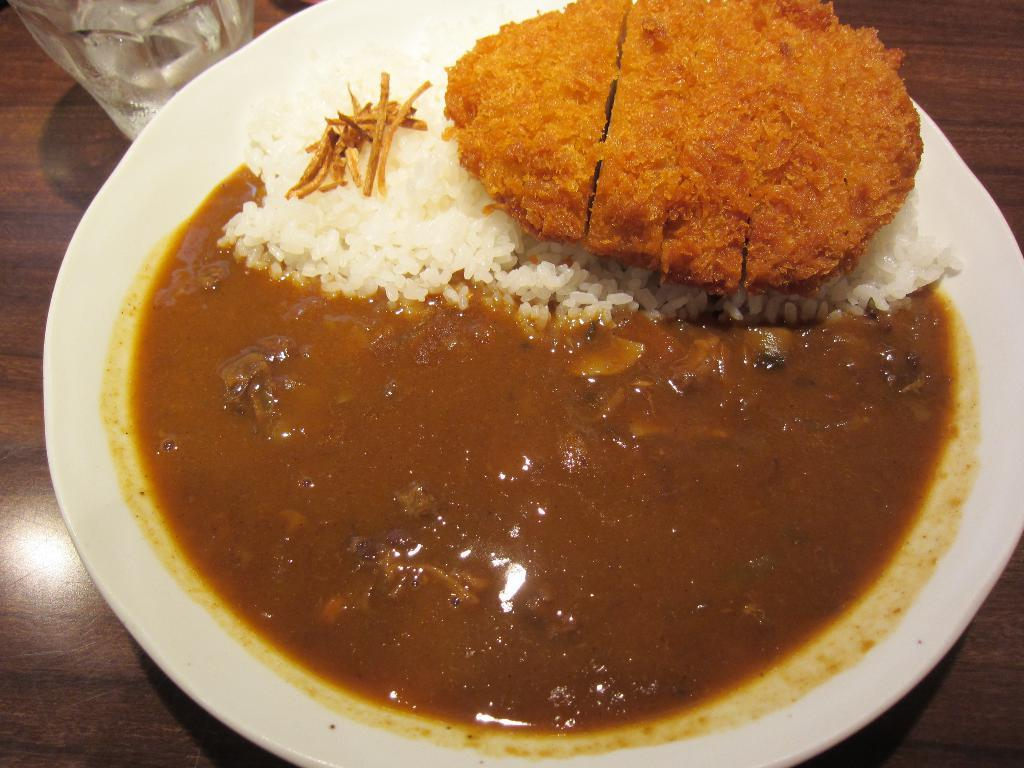What is on the plate in the image? There are food items on a plate in the image. What else can be seen on the wooden surface in the image? There is a glass on a wooden surface in the image. What type of patch is visible on the food items in the image? There is no patch visible on the food items in the image. What kind of fuel is being used by the spacecraft in the image? There is no spacecraft or fuel present in the image; it only features food items on a plate and a glass on a wooden surface. 